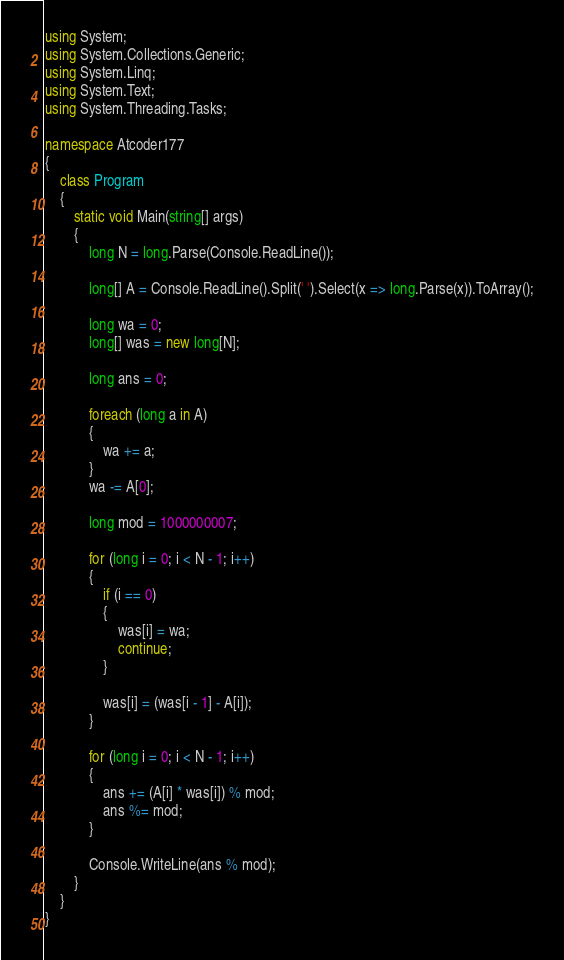<code> <loc_0><loc_0><loc_500><loc_500><_C#_>using System;
using System.Collections.Generic;
using System.Linq;
using System.Text;
using System.Threading.Tasks;

namespace Atcoder177
{
    class Program
    {
        static void Main(string[] args)
        {
            long N = long.Parse(Console.ReadLine());

            long[] A = Console.ReadLine().Split(' ').Select(x => long.Parse(x)).ToArray();

            long wa = 0;
            long[] was = new long[N];

            long ans = 0;

            foreach (long a in A)
            {
                wa += a;
            }
            wa -= A[0];

            long mod = 1000000007;

            for (long i = 0; i < N - 1; i++)
            {
                if (i == 0)
                {
                    was[i] = wa;
                    continue;
                }

                was[i] = (was[i - 1] - A[i]);
            }

            for (long i = 0; i < N - 1; i++)
            {
                ans += (A[i] * was[i]) % mod;
                ans %= mod;
            }

            Console.WriteLine(ans % mod);
        }
    }
}
</code> 